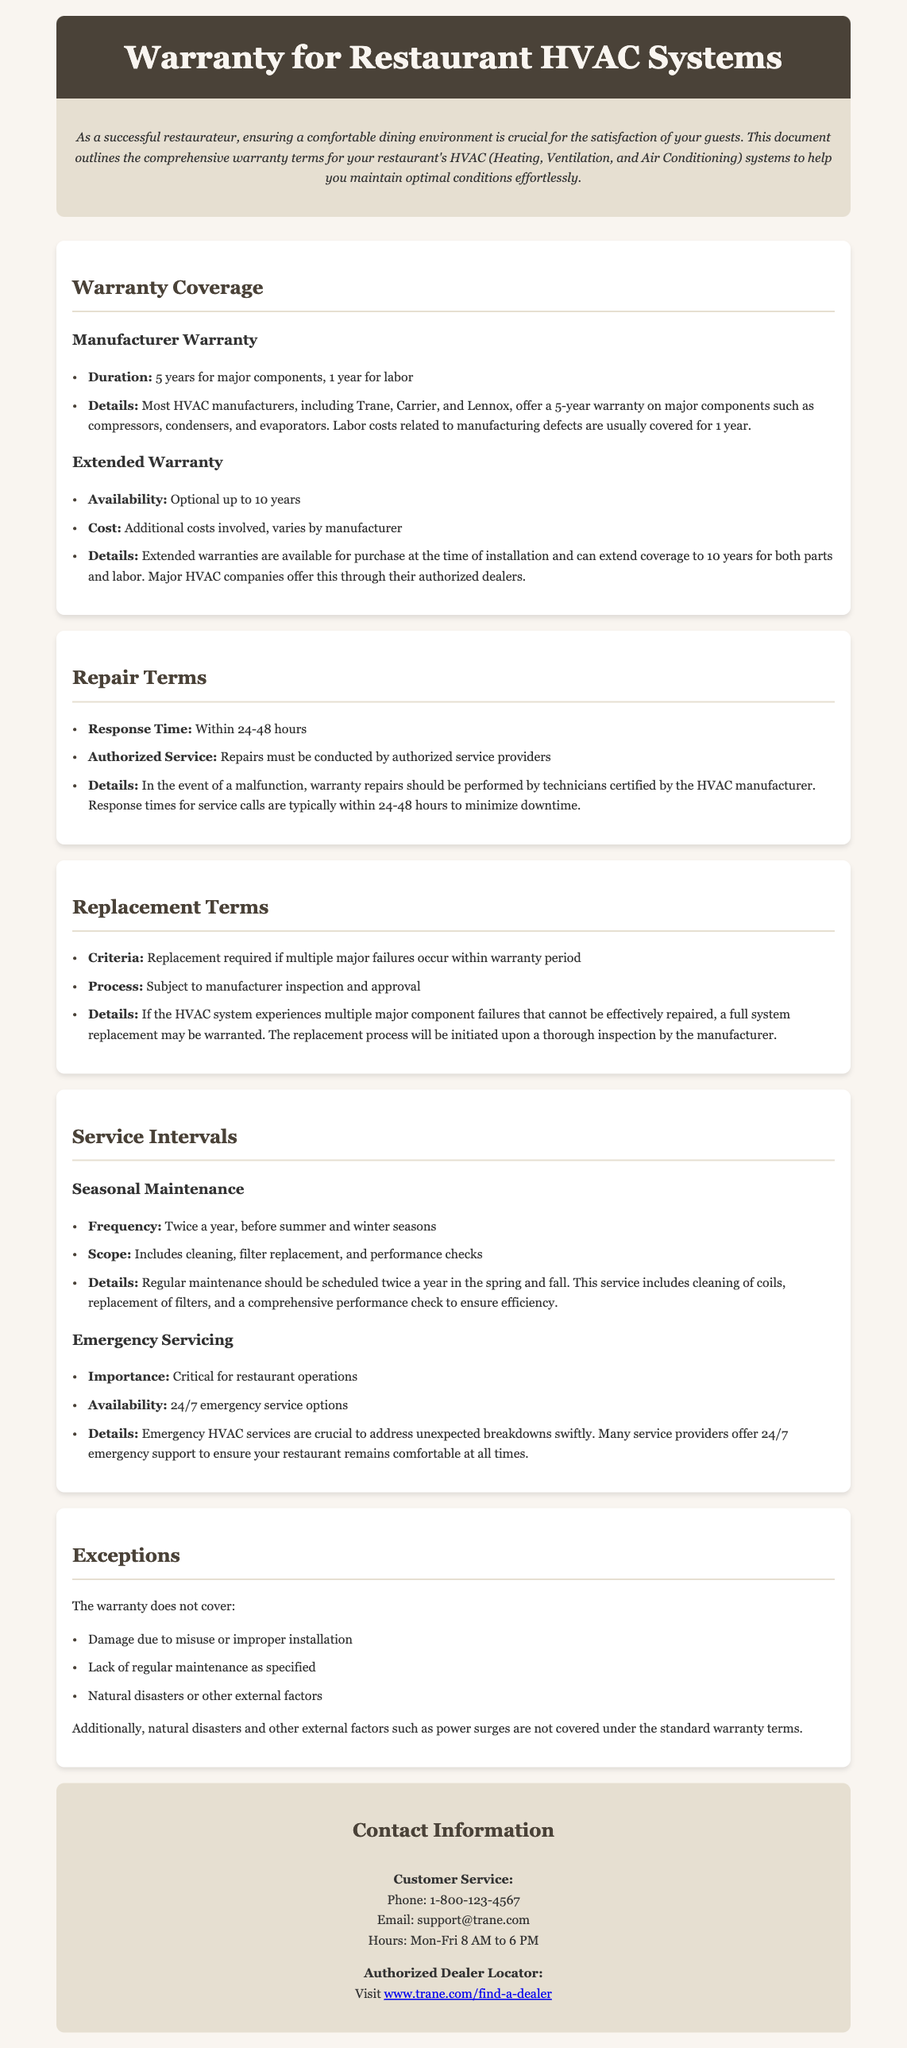What is the duration of the manufacturer warranty? The document specifies that the manufacturer warranty lasts for 5 years for major components and 1 year for labor.
Answer: 5 years What is the response time for warranty repairs? The document states that the response time for warranty repairs is typically within 24-48 hours.
Answer: 24-48 hours What is the maximum duration of the extended warranty? The document mentions that the extended warranty can be purchased to extend coverage up to 10 years.
Answer: 10 years What must be included in seasonal maintenance? The document details that seasonal maintenance includes cleaning, filter replacement, and performance checks.
Answer: Cleaning, filter replacement, and performance checks What factors are not covered by the warranty? The document lists that damage due to misuse, lack of maintenance, and natural disasters are not covered.
Answer: Misuse, lack of maintenance, and natural disasters Under what condition is a full system replacement warranted? The document states that a full system replacement is warranted if multiple major failures occur within the warranty period.
Answer: Multiple major failures What is the cost implication of an extended warranty? The document notes that there are additional costs involved for the extended warranty, which varies by manufacturer.
Answer: Additional costs What is the frequency of the recommended seasonal maintenance? The document indicates that seasonal maintenance should be scheduled twice a year.
Answer: Twice a year What service availability is crucial for restaurant operations? The document emphasizes that emergency servicing is critical for maintaining restaurant operations.
Answer: Emergency servicing 